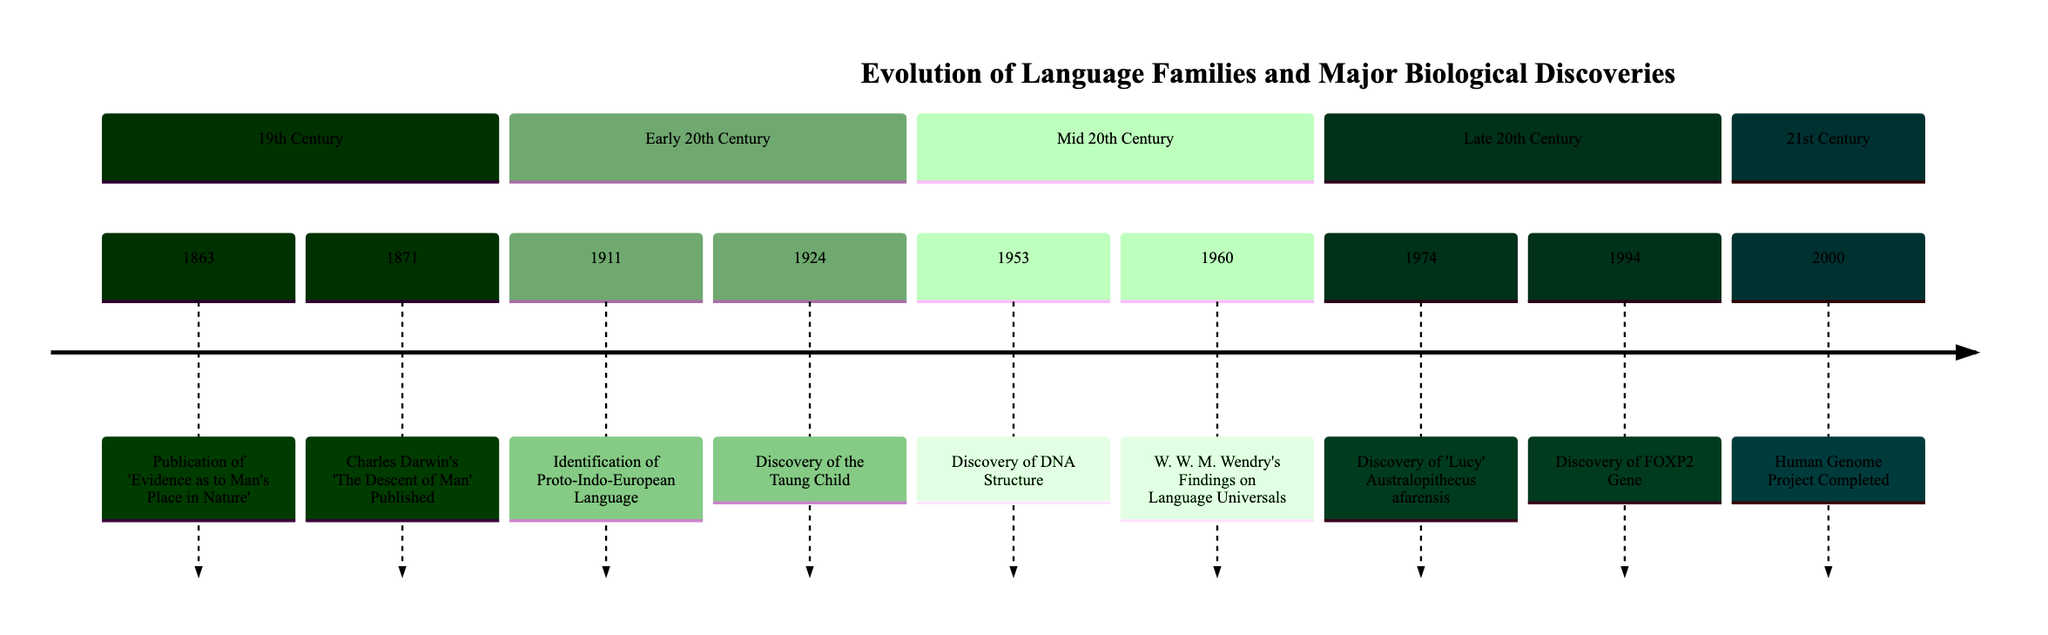What year was the publication of 'Evidence as to Man's Place in Nature'? The diagram indicates that 'Evidence as to Man's Place in Nature' was published in 1863, as shown in the 19th Century section.
Answer: 1863 What event is linked with the discovery of the FOXP2 Gene? The FOXP2 Gene discovery is listed in 1994, correlating it with language abilities in the Late 20th Century section of the diagram.
Answer: Discovery of FOXP2 Gene How many events occurred in the Early 20th Century? The Early 20th Century section shows two events: the Identification of Proto-Indo-European Language in 1911 and the Discovery of the Taung Child in 1924. Thus, there are two events.
Answer: 2 What significant biological discovery occurred in 1953? The diagram specifies that in 1953, the Discovery of DNA Structure occurred, indicating a major biological advancement relevant to language evolution.
Answer: Discovery of DNA Structure Which event suggests parallel developments in cognitive abilities required for language? The Discovery of the Taung Child in 1924 is highlighted in the diagram, as it indicates important cognitive abilities relevant to language development.
Answer: Discovery of the Taung Child What is the most recent event in the timeline? The most recent event listed in the timeline is the completion of the Human Genome Project in 2000, found in the 21st Century section.
Answer: Human Genome Project Completed How does the discovery of Lucy contribute to language evolution hypotheses? The diagram shows that the Discovery of Lucy in 1974 provides insights into early human brain development and locomotion, suggesting potential links to vocal communication and language origins.
Answer: Insights into brain development What notable theory did Darwin introduce in 1871? In 1871, the publication of Darwin's 'The Descent of Man' introduced the theory of sexual selection, noted in the timeline for its connection to the development of complex languages.
Answer: Theory of sexual selection Which event laid the groundwork for exploring genetic links to language ability? The completion of the Human Genome Project in 2000 allowed for in-depth exploration of genetic connections to language abilities, indicated in the timeline.
Answer: Human Genome Project Completed 